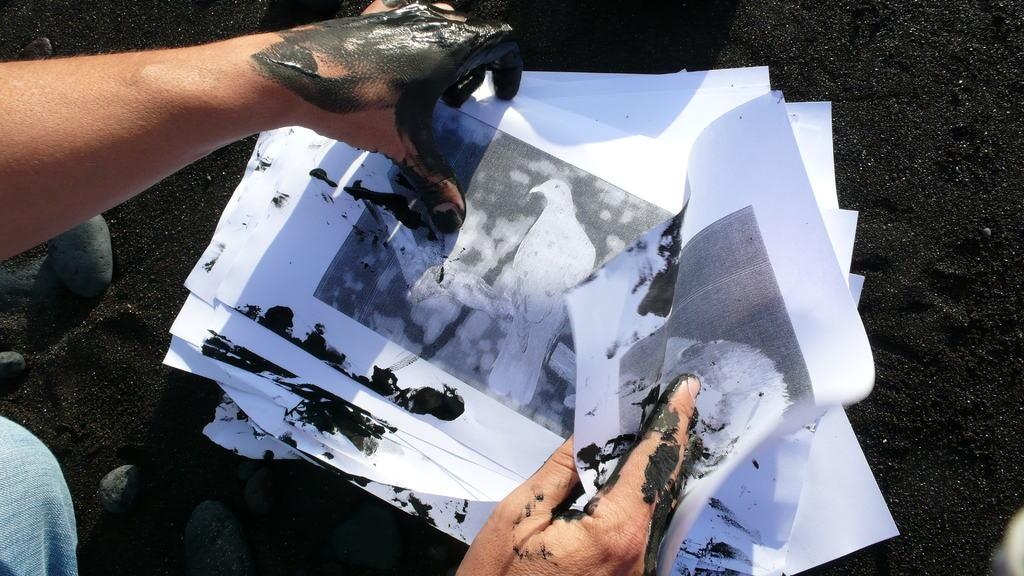What is the person holding in the image? The person is holding papers in the image. What can be seen on the person's hands? The person has black paint on their hands. What type of natural elements are visible in the background of the image? There are stones and black soil visible in the background of the image. What type of government is depicted in the image? There is no depiction of a government in the image; it features a person holding papers with black paint on their hands and a background with stones and black soil. Can you see a train in the image? There is no train present in the image. 